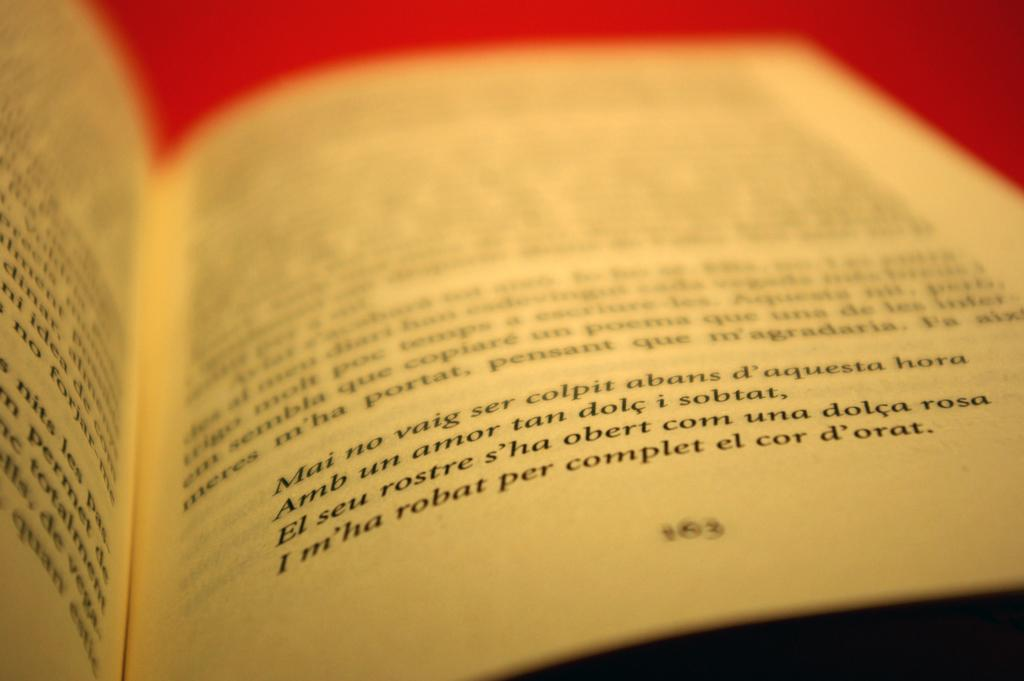<image>
Relay a brief, clear account of the picture shown. An open book shows a page with a passage in French that ends with the word "d'orat." 